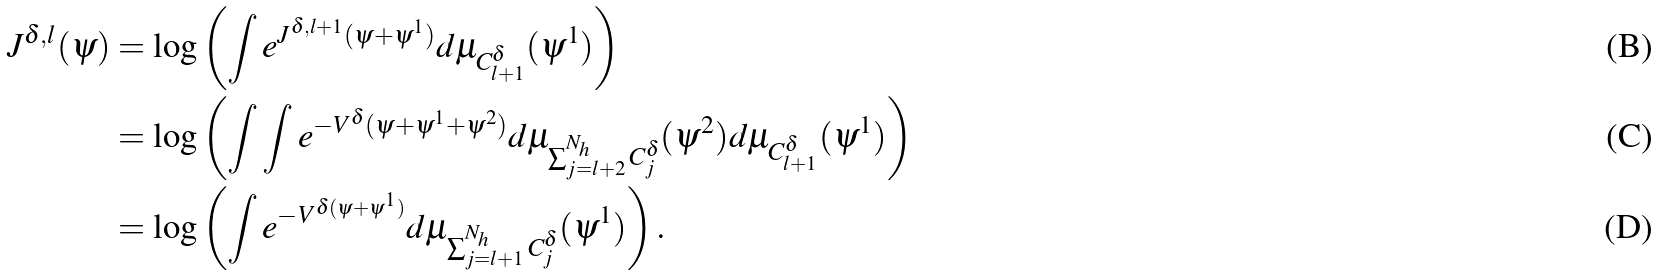Convert formula to latex. <formula><loc_0><loc_0><loc_500><loc_500>J ^ { \delta , l } ( \psi ) & = \log \left ( \int e ^ { J ^ { \delta , l + 1 } ( \psi + \psi ^ { 1 } ) } d \mu _ { C _ { l + 1 } ^ { \delta } } ( \psi ^ { 1 } ) \right ) \\ & = \log \left ( \int \int e ^ { - V ^ { \delta } ( \psi + \psi ^ { 1 } + \psi ^ { 2 } ) } d \mu _ { \sum _ { j = l + 2 } ^ { N _ { h } } C _ { j } ^ { \delta } } ( \psi ^ { 2 } ) d \mu _ { C _ { l + 1 } ^ { \delta } } ( \psi ^ { 1 } ) \right ) \\ & = \log \left ( \int e ^ { - V ^ { \delta ( \psi + \psi ^ { 1 } ) } } d \mu _ { \sum _ { j = l + 1 } ^ { N _ { h } } C _ { j } ^ { \delta } } ( \psi ^ { 1 } ) \right ) .</formula> 